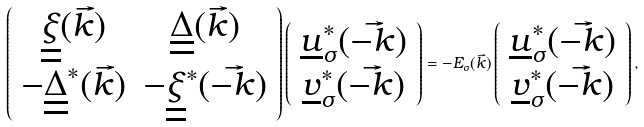Convert formula to latex. <formula><loc_0><loc_0><loc_500><loc_500>\left ( \begin{array} { c c } \underline { \underline { \xi } } ( { \vec { k } } ) & \underline { \underline { \Delta } } ( { \vec { k } } ) \\ - \underline { \underline { \Delta } } ^ { * } ( { \vec { k } } ) & - \underline { \underline { \xi } } ^ { * } ( { \vec { - k } } ) \end{array} \right ) \left ( \begin{array} { c } \underline { u } ^ { * } _ { \sigma } ( { \vec { - k } } ) \\ \underline { v } ^ { * } _ { \sigma } ( { \vec { - k } } ) \end{array} \right ) = - E _ { \sigma } ( { \vec { k } } ) \left ( \begin{array} { c } \underline { u } ^ { * } _ { \sigma } ( { \vec { - k } } ) \\ \underline { v } ^ { * } _ { \sigma } ( { \vec { - k } } ) \end{array} \right ) ,</formula> 